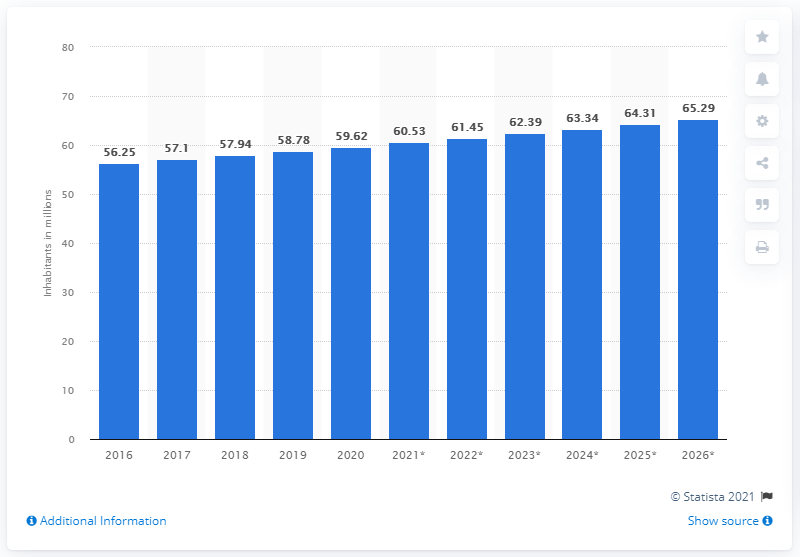Draw attention to some important aspects in this diagram. In 2020, the population of South Africa was approximately 59.62 million people. The population of South Africa ended in 2020. 